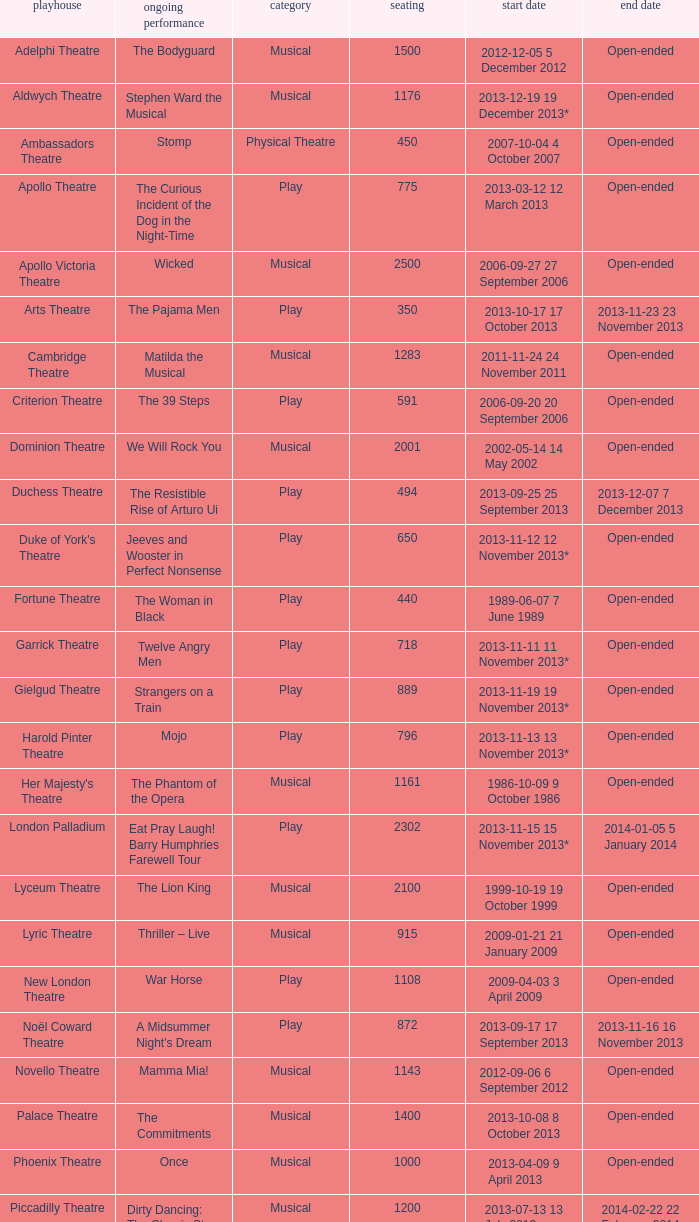What opening date has a capacity of 100? 2013-11-01 1 November 2013. Can you parse all the data within this table? {'header': ['playhouse', 'ongoing performance', 'category', 'seating', 'start date', 'end date'], 'rows': [['Adelphi Theatre', 'The Bodyguard', 'Musical', '1500', '2012-12-05 5 December 2012', 'Open-ended'], ['Aldwych Theatre', 'Stephen Ward the Musical', 'Musical', '1176', '2013-12-19 19 December 2013*', 'Open-ended'], ['Ambassadors Theatre', 'Stomp', 'Physical Theatre', '450', '2007-10-04 4 October 2007', 'Open-ended'], ['Apollo Theatre', 'The Curious Incident of the Dog in the Night-Time', 'Play', '775', '2013-03-12 12 March 2013', 'Open-ended'], ['Apollo Victoria Theatre', 'Wicked', 'Musical', '2500', '2006-09-27 27 September 2006', 'Open-ended'], ['Arts Theatre', 'The Pajama Men', 'Play', '350', '2013-10-17 17 October 2013', '2013-11-23 23 November 2013'], ['Cambridge Theatre', 'Matilda the Musical', 'Musical', '1283', '2011-11-24 24 November 2011', 'Open-ended'], ['Criterion Theatre', 'The 39 Steps', 'Play', '591', '2006-09-20 20 September 2006', 'Open-ended'], ['Dominion Theatre', 'We Will Rock You', 'Musical', '2001', '2002-05-14 14 May 2002', 'Open-ended'], ['Duchess Theatre', 'The Resistible Rise of Arturo Ui', 'Play', '494', '2013-09-25 25 September 2013', '2013-12-07 7 December 2013'], ["Duke of York's Theatre", 'Jeeves and Wooster in Perfect Nonsense', 'Play', '650', '2013-11-12 12 November 2013*', 'Open-ended'], ['Fortune Theatre', 'The Woman in Black', 'Play', '440', '1989-06-07 7 June 1989', 'Open-ended'], ['Garrick Theatre', 'Twelve Angry Men', 'Play', '718', '2013-11-11 11 November 2013*', 'Open-ended'], ['Gielgud Theatre', 'Strangers on a Train', 'Play', '889', '2013-11-19 19 November 2013*', 'Open-ended'], ['Harold Pinter Theatre', 'Mojo', 'Play', '796', '2013-11-13 13 November 2013*', 'Open-ended'], ["Her Majesty's Theatre", 'The Phantom of the Opera', 'Musical', '1161', '1986-10-09 9 October 1986', 'Open-ended'], ['London Palladium', 'Eat Pray Laugh! Barry Humphries Farewell Tour', 'Play', '2302', '2013-11-15 15 November 2013*', '2014-01-05 5 January 2014'], ['Lyceum Theatre', 'The Lion King', 'Musical', '2100', '1999-10-19 19 October 1999', 'Open-ended'], ['Lyric Theatre', 'Thriller – Live', 'Musical', '915', '2009-01-21 21 January 2009', 'Open-ended'], ['New London Theatre', 'War Horse', 'Play', '1108', '2009-04-03 3 April 2009', 'Open-ended'], ['Noël Coward Theatre', "A Midsummer Night's Dream", 'Play', '872', '2013-09-17 17 September 2013', '2013-11-16 16 November 2013'], ['Novello Theatre', 'Mamma Mia!', 'Musical', '1143', '2012-09-06 6 September 2012', 'Open-ended'], ['Palace Theatre', 'The Commitments', 'Musical', '1400', '2013-10-08 8 October 2013', 'Open-ended'], ['Phoenix Theatre', 'Once', 'Musical', '1000', '2013-04-09 9 April 2013', 'Open-ended'], ['Piccadilly Theatre', 'Dirty Dancing: The Classic Story on Stage', 'Musical', '1200', '2013-07-13 13 July 2013', '2014-02-22 22 February 2014'], ['Playhouse Theatre', "Monty Python's Spamalot", 'Musical', '786', '2012-11-20 20 November 2012', 'Open-ended'], ['Prince Edward Theatre', 'Jersey Boys', 'Musical', '1618', '2008-03-18 18 March 2008', '2014-03-09 9 March 2014'], ['Prince of Wales Theatre', 'The Book of Mormon', 'Musical', '1160', '2013-03-21 21 March 2013', 'Open-ended'], ["Queen's Theatre", 'Les Misérables', 'Musical', '1099', '2004-04-12 12 April 2004', 'Open-ended'], ['Savoy Theatre', 'Let It Be', 'Musical', '1158', '2013-02-01 1 February 2013', 'Open-ended'], ['Shaftesbury Theatre', 'From Here to Eternity the Musical', 'Musical', '1400', '2013-10-23 23 October 2013', 'Open-ended'], ['St. James Theatre', 'Scenes from a Marriage', 'Play', '312', '2013-09-11 11 September 2013', '2013-11-9 9 November 2013'], ["St Martin's Theatre", 'The Mousetrap', 'Play', '550', '1974-03-25 25 March 1974', 'Open-ended'], ['Theatre Royal, Haymarket', 'One Man, Two Guvnors', 'Play', '888', '2012-03-02 2 March 2012', '2013-03-01 1 March 2014'], ['Theatre Royal, Drury Lane', 'Charlie and the Chocolate Factory the Musical', 'Musical', '2220', '2013-06-25 25 June 2013', 'Open-ended'], ['Trafalgar Studios 1', 'The Pride', 'Play', '380', '2013-08-13 13 August 2013', '2013-11-23 23 November 2013'], ['Trafalgar Studios 2', 'Mrs. Lowry and Son', 'Play', '100', '2013-11-01 1 November 2013', '2013-11-23 23 November 2013'], ['Vaudeville Theatre', 'The Ladykillers', 'Play', '681', '2013-07-09 9 July 2013', '2013-11-16 16 November 2013'], ['Victoria Palace Theatre', 'Billy Elliot the Musical', 'Musical', '1517', '2005-05-11 11 May 2005', 'Open-ended'], ["Wyndham's Theatre", 'Barking in Essex', 'Play', '750', '2013-09-16 16 September 2013', '2014-01-04 4 January 2014']]} 